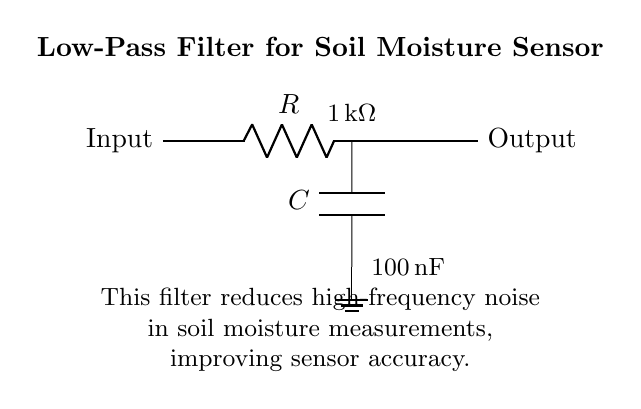What is the resistance value in the circuit? The resistance value is labeled as 1 kΩ in the diagram, indicating that the circuit includes a resistor with this value.
Answer: 1 kΩ What is the capacitance value used in this filter? The capacitance value is specified as 100 nF in the circuit diagram, showing that a capacitor of this value is part of the filter design.
Answer: 100 nF What is the main purpose of this low-pass filter? The explanation in the diagram states that the filter's purpose is to reduce high-frequency noise in soil moisture measurements, thus improving accuracy.
Answer: Reduce noise Which component is connected to ground in this circuit? The capacitor is directly connected to ground in the circuit, as indicated by the ground symbol next to it, verifying its role in filtering.
Answer: Capacitor How does the low-pass filter affect signal frequency? A low-pass filter is designed to allow low frequencies to pass while attenuating higher frequencies, which is essential for filtering out noise from the sensor data.
Answer: Attenuates high frequencies What type of circuit is depicted here? The diagram specifically represents a low-pass filter circuit, as identified by the configuration and components used (resistor and capacitor) tailored for filtering signals.
Answer: Low-pass filter What is connected to the output of the circuit? The output terminal of the circuit is connected directly after the capacitor, showing the filtered signal is taken from this point.
Answer: Output 